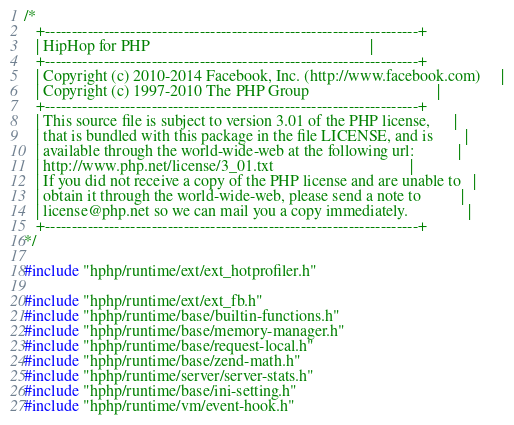Convert code to text. <code><loc_0><loc_0><loc_500><loc_500><_C++_>/*
   +----------------------------------------------------------------------+
   | HipHop for PHP                                                       |
   +----------------------------------------------------------------------+
   | Copyright (c) 2010-2014 Facebook, Inc. (http://www.facebook.com)     |
   | Copyright (c) 1997-2010 The PHP Group                                |
   +----------------------------------------------------------------------+
   | This source file is subject to version 3.01 of the PHP license,      |
   | that is bundled with this package in the file LICENSE, and is        |
   | available through the world-wide-web at the following url:           |
   | http://www.php.net/license/3_01.txt                                  |
   | If you did not receive a copy of the PHP license and are unable to   |
   | obtain it through the world-wide-web, please send a note to          |
   | license@php.net so we can mail you a copy immediately.               |
   +----------------------------------------------------------------------+
*/

#include "hphp/runtime/ext/ext_hotprofiler.h"

#include "hphp/runtime/ext/ext_fb.h"
#include "hphp/runtime/base/builtin-functions.h"
#include "hphp/runtime/base/memory-manager.h"
#include "hphp/runtime/base/request-local.h"
#include "hphp/runtime/base/zend-math.h"
#include "hphp/runtime/server/server-stats.h"
#include "hphp/runtime/base/ini-setting.h"
#include "hphp/runtime/vm/event-hook.h"</code> 